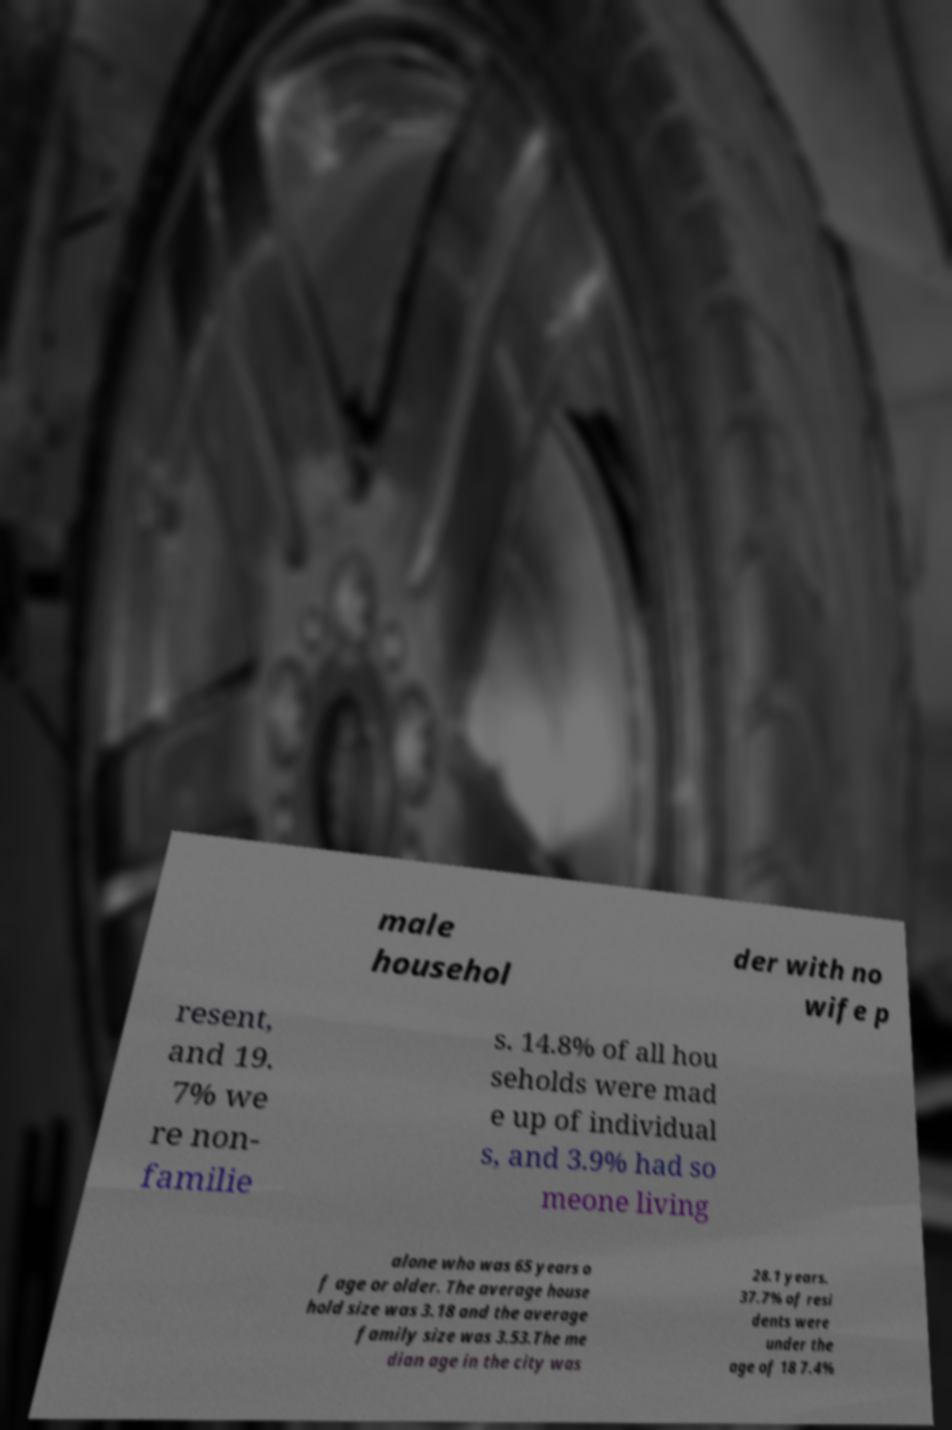Please identify and transcribe the text found in this image. male househol der with no wife p resent, and 19. 7% we re non- familie s. 14.8% of all hou seholds were mad e up of individual s, and 3.9% had so meone living alone who was 65 years o f age or older. The average house hold size was 3.18 and the average family size was 3.53.The me dian age in the city was 28.1 years. 37.7% of resi dents were under the age of 18 7.4% 